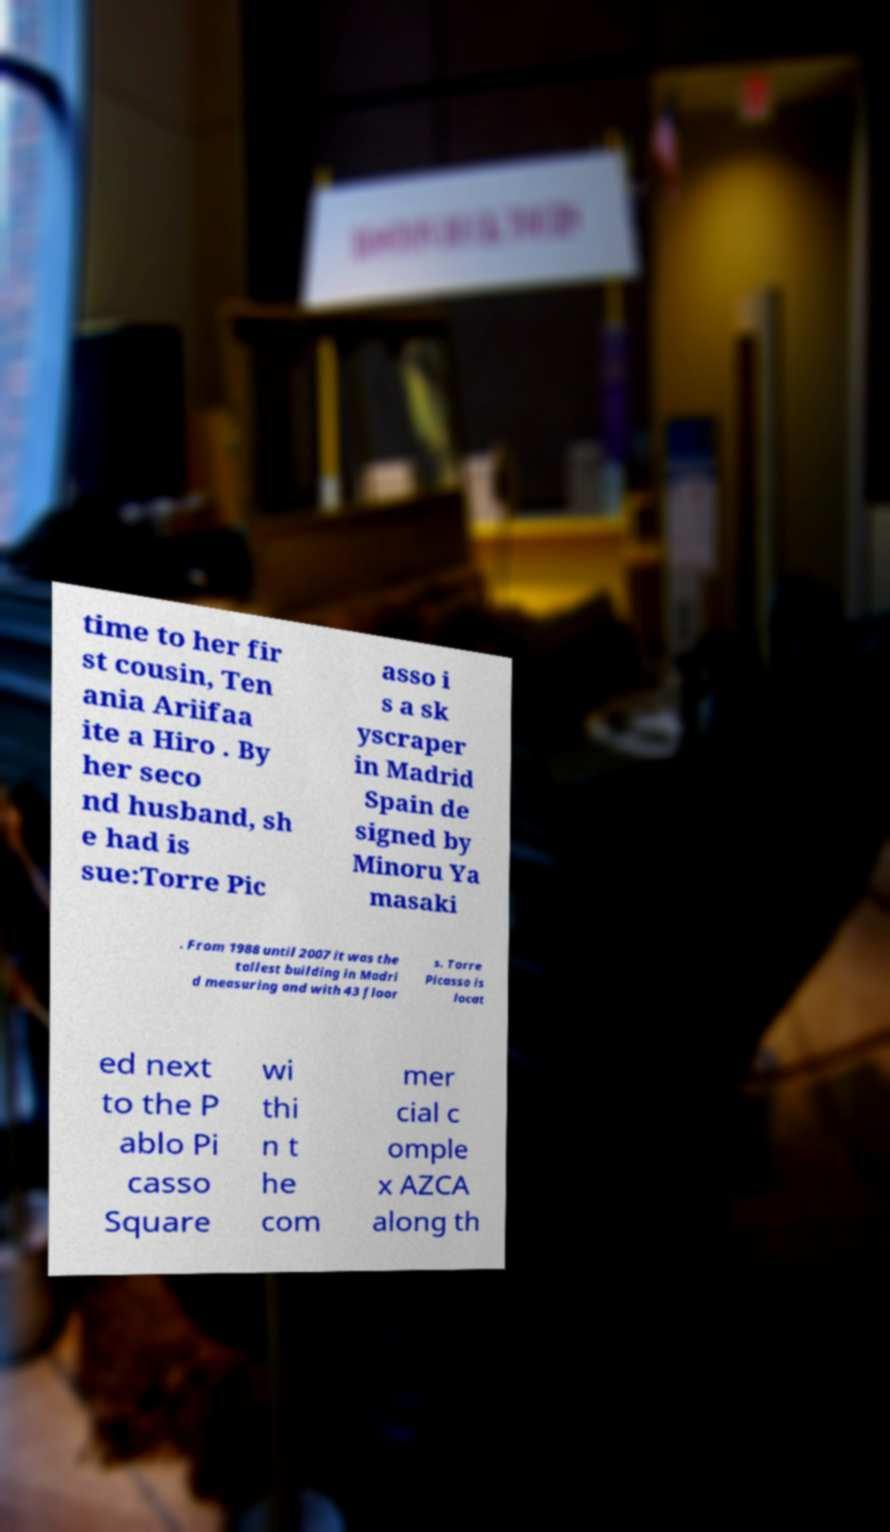For documentation purposes, I need the text within this image transcribed. Could you provide that? time to her fir st cousin, Ten ania Ariifaa ite a Hiro . By her seco nd husband, sh e had is sue:Torre Pic asso i s a sk yscraper in Madrid Spain de signed by Minoru Ya masaki . From 1988 until 2007 it was the tallest building in Madri d measuring and with 43 floor s. Torre Picasso is locat ed next to the P ablo Pi casso Square wi thi n t he com mer cial c omple x AZCA along th 